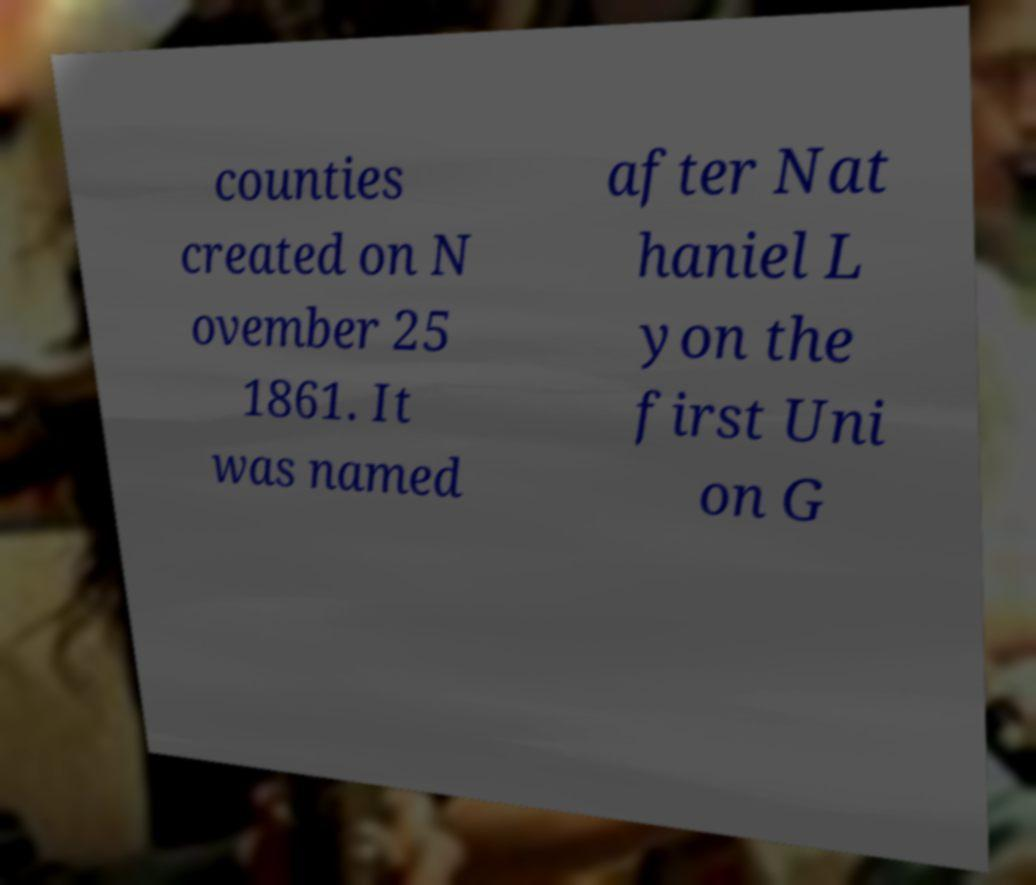I need the written content from this picture converted into text. Can you do that? counties created on N ovember 25 1861. It was named after Nat haniel L yon the first Uni on G 